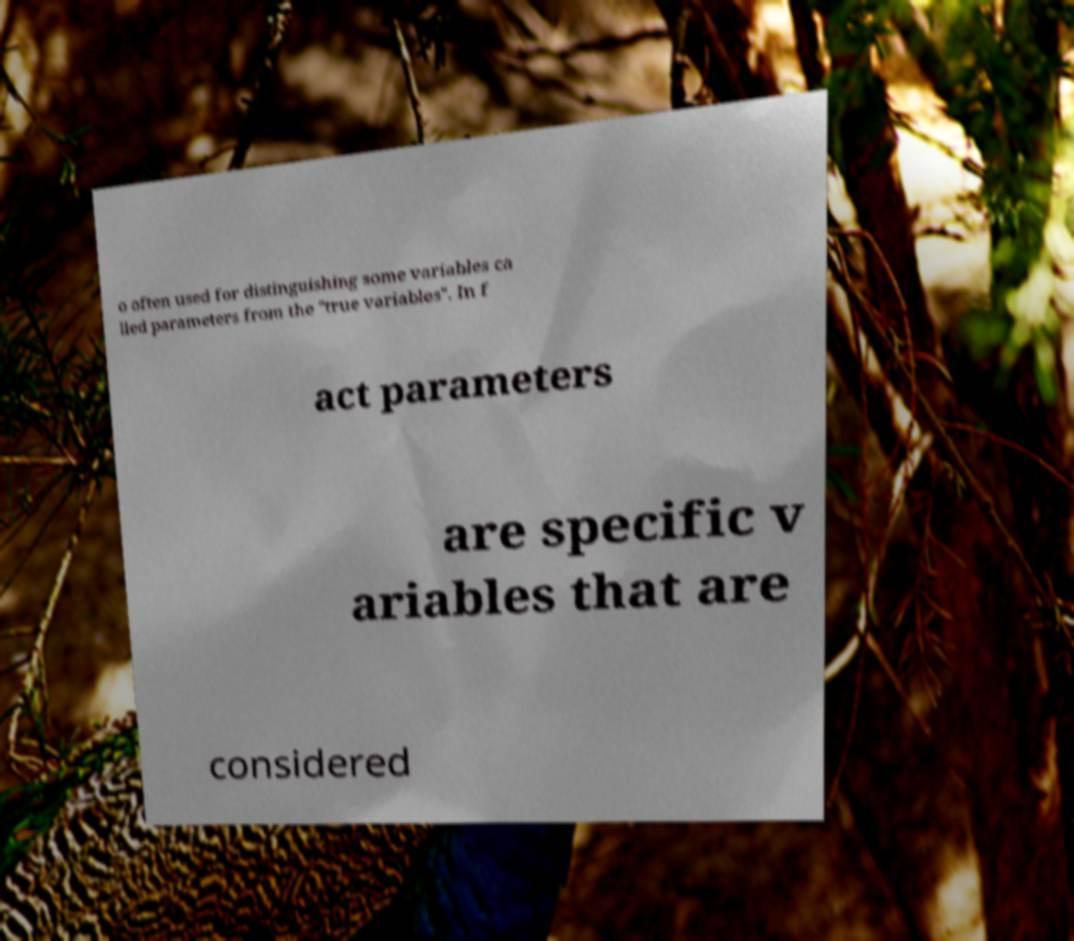I need the written content from this picture converted into text. Can you do that? o often used for distinguishing some variables ca lled parameters from the "true variables". In f act parameters are specific v ariables that are considered 